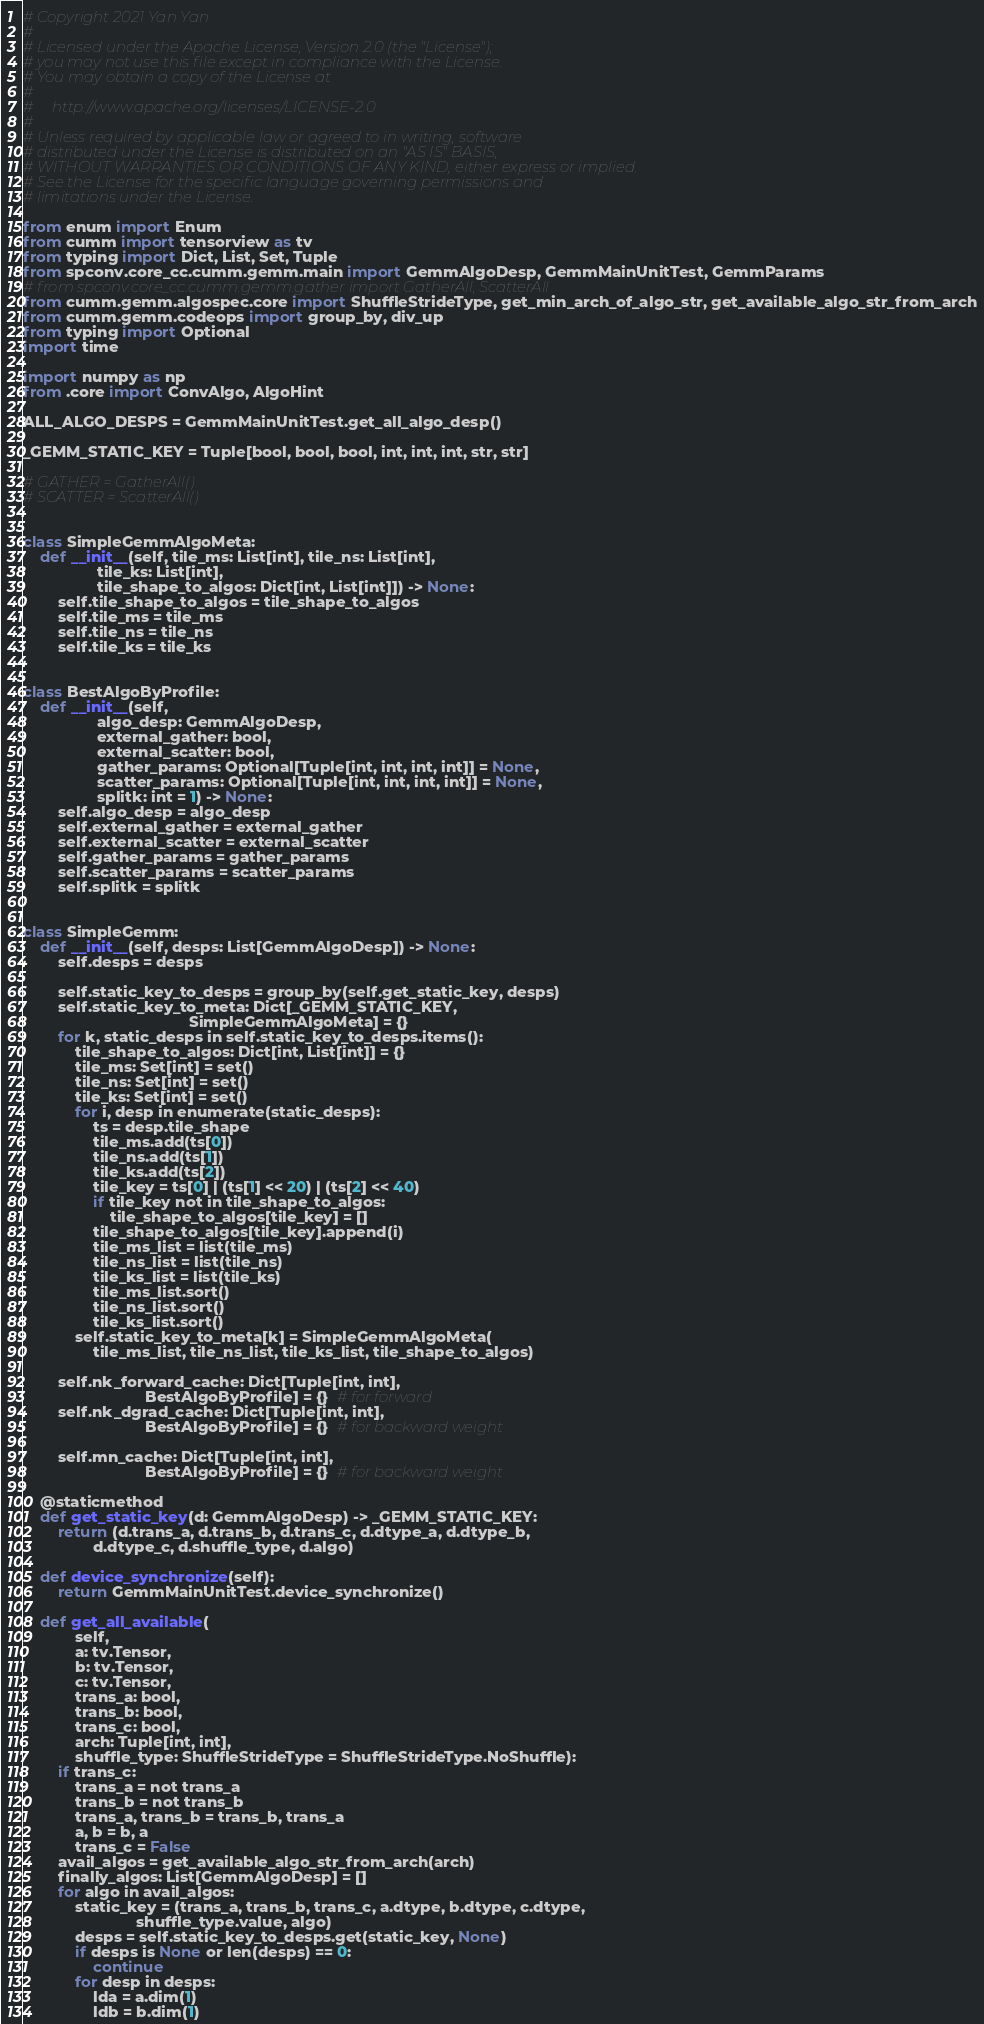<code> <loc_0><loc_0><loc_500><loc_500><_Python_># Copyright 2021 Yan Yan
#
# Licensed under the Apache License, Version 2.0 (the "License");
# you may not use this file except in compliance with the License.
# You may obtain a copy of the License at
#
#     http://www.apache.org/licenses/LICENSE-2.0
#
# Unless required by applicable law or agreed to in writing, software
# distributed under the License is distributed on an "AS IS" BASIS,
# WITHOUT WARRANTIES OR CONDITIONS OF ANY KIND, either express or implied.
# See the License for the specific language governing permissions and
# limitations under the License.

from enum import Enum
from cumm import tensorview as tv
from typing import Dict, List, Set, Tuple
from spconv.core_cc.cumm.gemm.main import GemmAlgoDesp, GemmMainUnitTest, GemmParams
# from spconv.core_cc.cumm.gemm.gather import GatherAll, ScatterAll
from cumm.gemm.algospec.core import ShuffleStrideType, get_min_arch_of_algo_str, get_available_algo_str_from_arch
from cumm.gemm.codeops import group_by, div_up
from typing import Optional
import time

import numpy as np
from .core import ConvAlgo, AlgoHint

ALL_ALGO_DESPS = GemmMainUnitTest.get_all_algo_desp()

_GEMM_STATIC_KEY = Tuple[bool, bool, bool, int, int, int, str, str]

# GATHER = GatherAll()
# SCATTER = ScatterAll()


class SimpleGemmAlgoMeta:
    def __init__(self, tile_ms: List[int], tile_ns: List[int],
                 tile_ks: List[int],
                 tile_shape_to_algos: Dict[int, List[int]]) -> None:
        self.tile_shape_to_algos = tile_shape_to_algos
        self.tile_ms = tile_ms
        self.tile_ns = tile_ns
        self.tile_ks = tile_ks


class BestAlgoByProfile:
    def __init__(self,
                 algo_desp: GemmAlgoDesp,
                 external_gather: bool,
                 external_scatter: bool,
                 gather_params: Optional[Tuple[int, int, int, int]] = None,
                 scatter_params: Optional[Tuple[int, int, int, int]] = None,
                 splitk: int = 1) -> None:
        self.algo_desp = algo_desp
        self.external_gather = external_gather
        self.external_scatter = external_scatter
        self.gather_params = gather_params
        self.scatter_params = scatter_params
        self.splitk = splitk


class SimpleGemm:
    def __init__(self, desps: List[GemmAlgoDesp]) -> None:
        self.desps = desps

        self.static_key_to_desps = group_by(self.get_static_key, desps)
        self.static_key_to_meta: Dict[_GEMM_STATIC_KEY,
                                      SimpleGemmAlgoMeta] = {}
        for k, static_desps in self.static_key_to_desps.items():
            tile_shape_to_algos: Dict[int, List[int]] = {}
            tile_ms: Set[int] = set()
            tile_ns: Set[int] = set()
            tile_ks: Set[int] = set()
            for i, desp in enumerate(static_desps):
                ts = desp.tile_shape
                tile_ms.add(ts[0])
                tile_ns.add(ts[1])
                tile_ks.add(ts[2])
                tile_key = ts[0] | (ts[1] << 20) | (ts[2] << 40)
                if tile_key not in tile_shape_to_algos:
                    tile_shape_to_algos[tile_key] = []
                tile_shape_to_algos[tile_key].append(i)
                tile_ms_list = list(tile_ms)
                tile_ns_list = list(tile_ns)
                tile_ks_list = list(tile_ks)
                tile_ms_list.sort()
                tile_ns_list.sort()
                tile_ks_list.sort()
            self.static_key_to_meta[k] = SimpleGemmAlgoMeta(
                tile_ms_list, tile_ns_list, tile_ks_list, tile_shape_to_algos)

        self.nk_forward_cache: Dict[Tuple[int, int],
                            BestAlgoByProfile] = {}  # for forward
        self.nk_dgrad_cache: Dict[Tuple[int, int],
                            BestAlgoByProfile] = {}  # for backward weight

        self.mn_cache: Dict[Tuple[int, int],
                            BestAlgoByProfile] = {}  # for backward weight

    @staticmethod
    def get_static_key(d: GemmAlgoDesp) -> _GEMM_STATIC_KEY:
        return (d.trans_a, d.trans_b, d.trans_c, d.dtype_a, d.dtype_b,
                d.dtype_c, d.shuffle_type, d.algo)

    def device_synchronize(self):
        return GemmMainUnitTest.device_synchronize()

    def get_all_available(
            self,
            a: tv.Tensor,
            b: tv.Tensor,
            c: tv.Tensor,
            trans_a: bool,
            trans_b: bool,
            trans_c: bool,
            arch: Tuple[int, int],
            shuffle_type: ShuffleStrideType = ShuffleStrideType.NoShuffle):
        if trans_c:
            trans_a = not trans_a
            trans_b = not trans_b
            trans_a, trans_b = trans_b, trans_a
            a, b = b, a
            trans_c = False
        avail_algos = get_available_algo_str_from_arch(arch)
        finally_algos: List[GemmAlgoDesp] = []
        for algo in avail_algos:
            static_key = (trans_a, trans_b, trans_c, a.dtype, b.dtype, c.dtype,
                          shuffle_type.value, algo)
            desps = self.static_key_to_desps.get(static_key, None)
            if desps is None or len(desps) == 0:
                continue
            for desp in desps:
                lda = a.dim(1)
                ldb = b.dim(1)</code> 